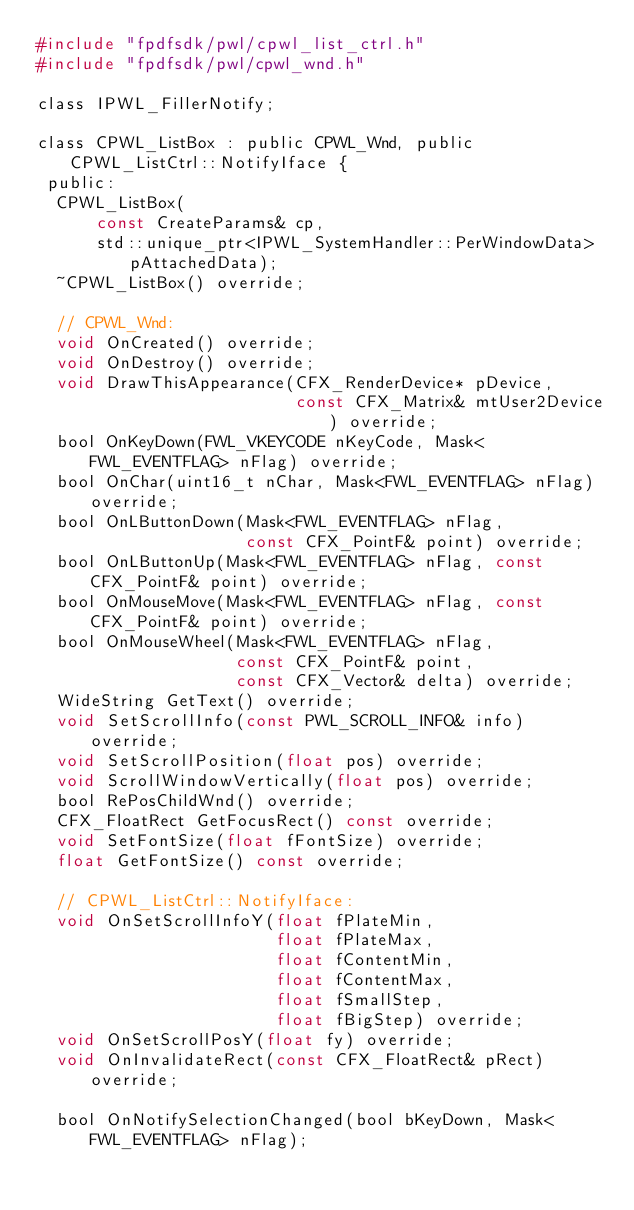Convert code to text. <code><loc_0><loc_0><loc_500><loc_500><_C_>#include "fpdfsdk/pwl/cpwl_list_ctrl.h"
#include "fpdfsdk/pwl/cpwl_wnd.h"

class IPWL_FillerNotify;

class CPWL_ListBox : public CPWL_Wnd, public CPWL_ListCtrl::NotifyIface {
 public:
  CPWL_ListBox(
      const CreateParams& cp,
      std::unique_ptr<IPWL_SystemHandler::PerWindowData> pAttachedData);
  ~CPWL_ListBox() override;

  // CPWL_Wnd:
  void OnCreated() override;
  void OnDestroy() override;
  void DrawThisAppearance(CFX_RenderDevice* pDevice,
                          const CFX_Matrix& mtUser2Device) override;
  bool OnKeyDown(FWL_VKEYCODE nKeyCode, Mask<FWL_EVENTFLAG> nFlag) override;
  bool OnChar(uint16_t nChar, Mask<FWL_EVENTFLAG> nFlag) override;
  bool OnLButtonDown(Mask<FWL_EVENTFLAG> nFlag,
                     const CFX_PointF& point) override;
  bool OnLButtonUp(Mask<FWL_EVENTFLAG> nFlag, const CFX_PointF& point) override;
  bool OnMouseMove(Mask<FWL_EVENTFLAG> nFlag, const CFX_PointF& point) override;
  bool OnMouseWheel(Mask<FWL_EVENTFLAG> nFlag,
                    const CFX_PointF& point,
                    const CFX_Vector& delta) override;
  WideString GetText() override;
  void SetScrollInfo(const PWL_SCROLL_INFO& info) override;
  void SetScrollPosition(float pos) override;
  void ScrollWindowVertically(float pos) override;
  bool RePosChildWnd() override;
  CFX_FloatRect GetFocusRect() const override;
  void SetFontSize(float fFontSize) override;
  float GetFontSize() const override;

  // CPWL_ListCtrl::NotifyIface:
  void OnSetScrollInfoY(float fPlateMin,
                        float fPlateMax,
                        float fContentMin,
                        float fContentMax,
                        float fSmallStep,
                        float fBigStep) override;
  void OnSetScrollPosY(float fy) override;
  void OnInvalidateRect(const CFX_FloatRect& pRect) override;

  bool OnNotifySelectionChanged(bool bKeyDown, Mask<FWL_EVENTFLAG> nFlag);
</code> 